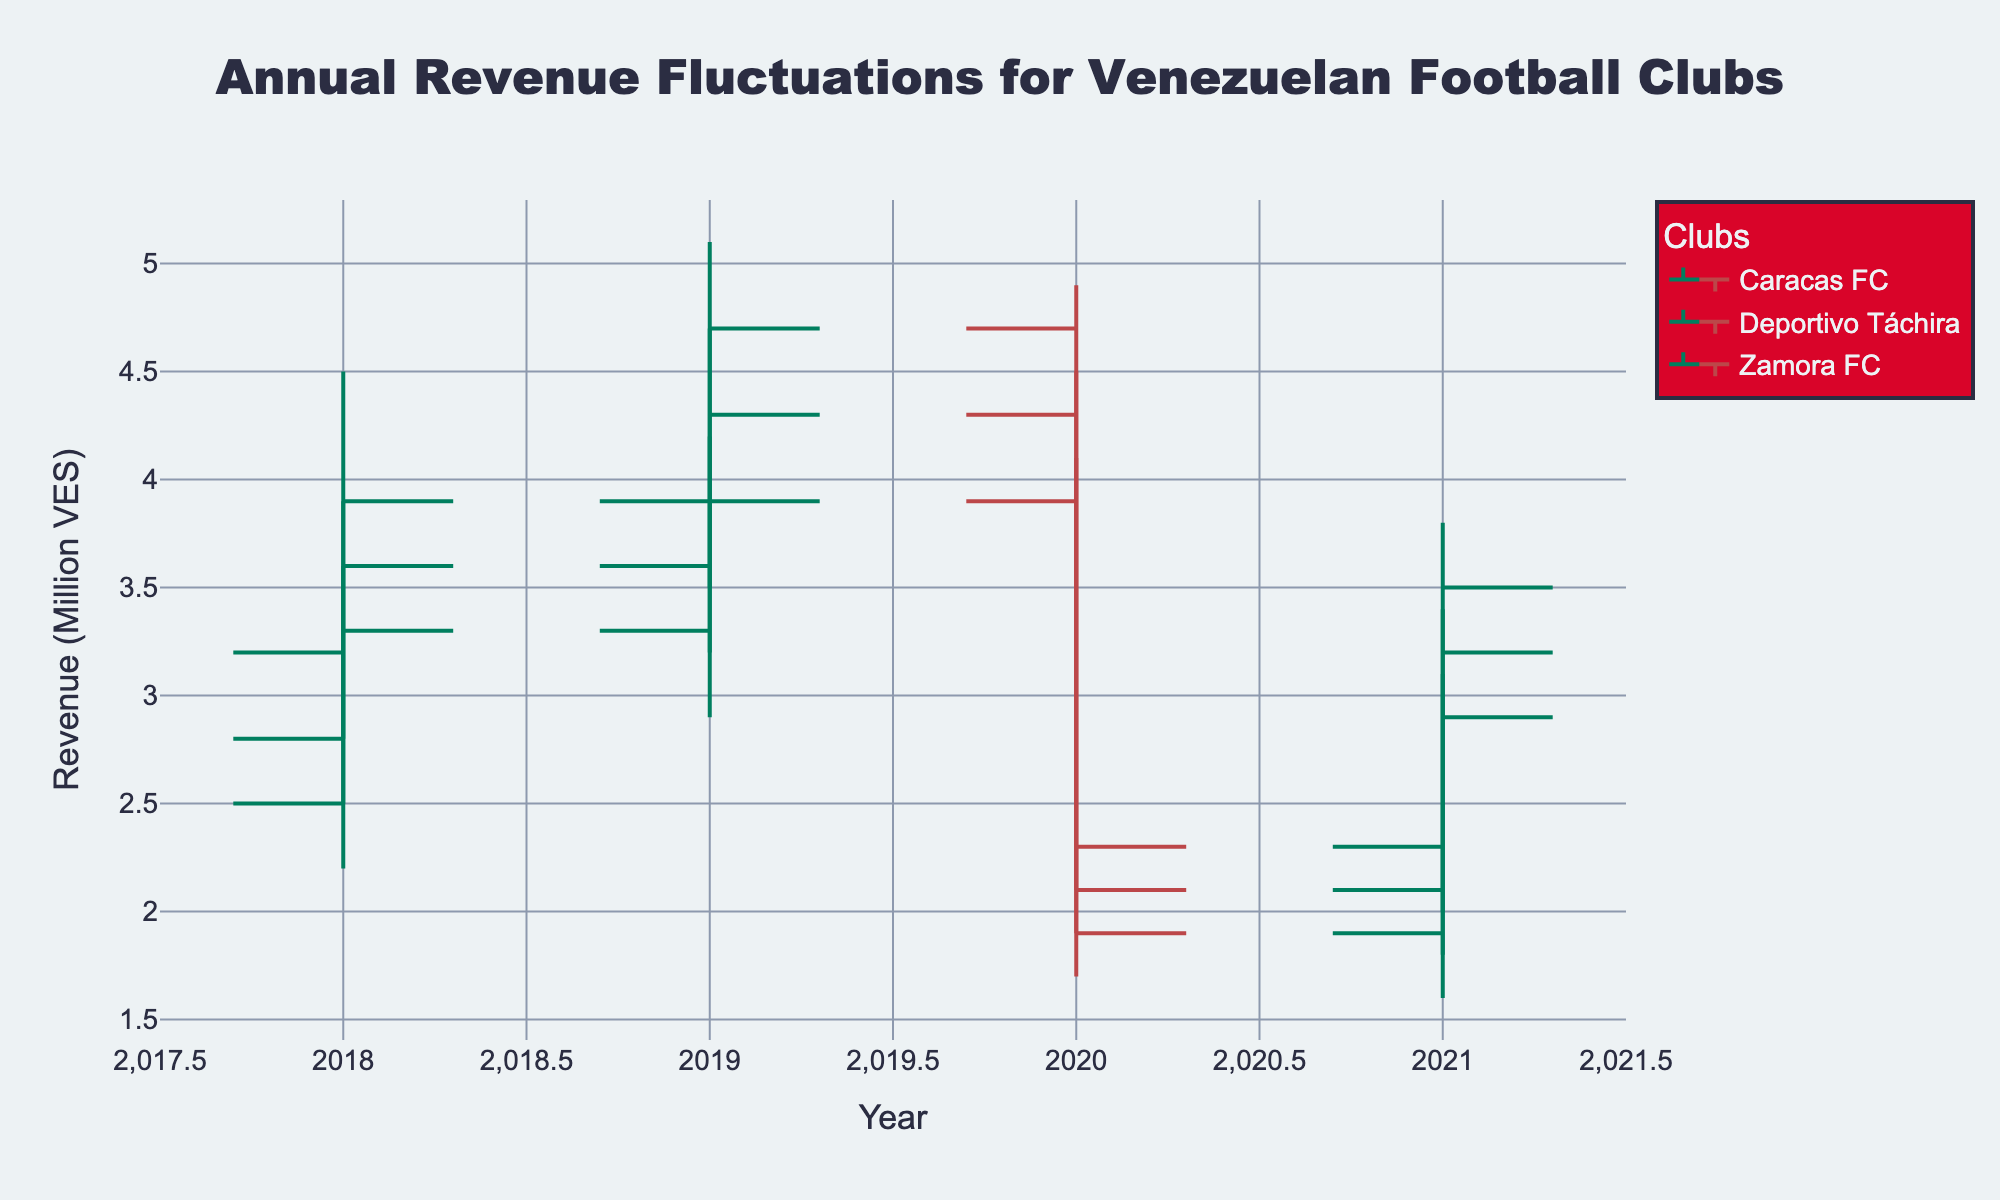What's the title of the figure? The figure's title is prominently displayed at the top, and it reads 'Annual Revenue Fluctuations for Venezuelan Football Clubs'.
Answer: Annual Revenue Fluctuations for Venezuelan Football Clubs Which club had the highest revenue in 2019 and what was it? We need to look at the highest point (High) for the year 2019 across all clubs. Caracas FC had the highest revenue at 5.1 million VES in 2019.
Answer: Caracas FC, 5.1 million VES In which year did Deportivo Táchira experience its lowest closing revenue and what was the value? We need to check the 'Close' values for Deportivo Táchira across all years. The lowest closing revenue for Deportivo Táchira was in 2020 at 2.1 million VES.
Answer: 2020, 2.1 million VES How did Caracas FC's closing revenue change from 2020 to 2021? Observe the 'Close' values for Caracas FC in 2020 and 2021. The closing revenue increased from 2.3 million VES in 2020 to 3.5 million VES in 2021. Calculate this change: 3.5 - 2.3 = 1.2 million VES.
Answer: Increased by 1.2 million VES Which club experienced the most significant drop in closing revenue from one year to the next? Compare the 'Close' values from year to year for each club. Caracas FC had the most significant drop from 2019 (4.7 million VES) to 2020 (2.3 million VES), a difference of 2.4 million VES.
Answer: Caracas FC What was the average high revenue for Zamora FC over the four years? Add the 'High' values for Zamora FC from 2018 to 2021: 3.6 + 4.2 + 4.1 + 3.1 = 15. Then divide by 4 to find the average: 15 / 4 = 3.75 million VES.
Answer: 3.75 million VES Compare the opening revenues of Caracas FC and Deportivo Táchira in 2018. Which club had a higher opening revenue and by how much? Look at the 'Open' values for both clubs in 2018. Caracas FC had 3.2 million VES while Deportivo Táchira had 2.8 million VES. The difference is 3.2 - 2.8 = 0.4 million VES.
Answer: Caracas FC by 0.4 million VES In which year did Zamora FC have the smallest range between its highest and lowest revenues, and what was the range? Calculate the range (High - Low) for each year for Zamora FC. The smallest range was in 2021, with High = 3.1 and Low = 1.6, thus the range is 3.1 - 1.6 = 1.5 million VES.
Answer: 2021, 1.5 million VES How much did Deportivo Táchira's merchandise revenue increase from 2020 to 2021? Look at the 'Merchandise' values for Deportivo Táchira in 2020 (0.5 million VES) and 2021 (0.7 million VES). The increase is 0.7 - 0.5 = 0.2 million VES.
Answer: 0.2 million VES 